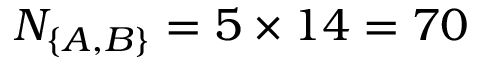<formula> <loc_0><loc_0><loc_500><loc_500>N _ { \{ A , B \} } = 5 \times 1 4 = 7 0</formula> 